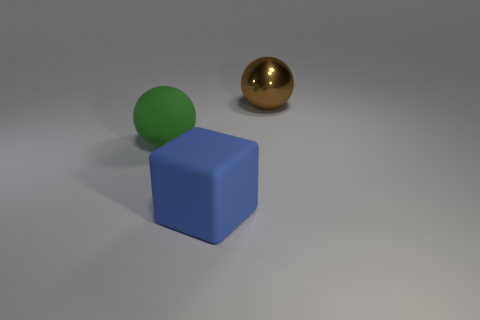Is there any indication of the size of these objects? The image does not provide direct indicators of scale such as familiar objects or a background with identifiable size references. Therefore, the true size of the objects remains ambiguous. Without additional context or points of reference, we can only speculate based on how such shapes commonly appear in the real world. 